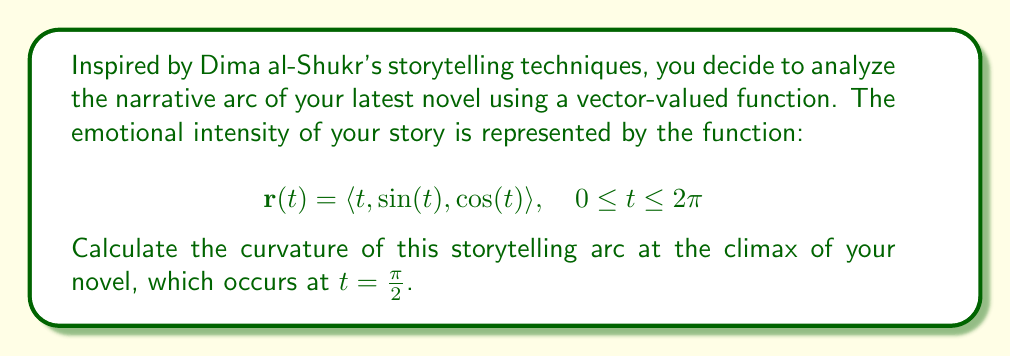What is the answer to this math problem? To calculate the curvature of a vector-valued function, we use the formula:

$$\kappa = \frac{|\mathbf{r}'(t) \times \mathbf{r}''(t)|}{|\mathbf{r}'(t)|^3}$$

Let's follow these steps:

1) First, calculate $\mathbf{r}'(t)$:
   $$\mathbf{r}'(t) = \langle 1, \cos(t), -\sin(t) \rangle$$

2) Then, calculate $\mathbf{r}''(t)$:
   $$\mathbf{r}''(t) = \langle 0, -\sin(t), -\cos(t) \rangle$$

3) Now, calculate $\mathbf{r}'(t) \times \mathbf{r}''(t)$:
   $$\begin{align}
   \mathbf{r}'(t) \times \mathbf{r}''(t) &= \begin{vmatrix} 
   \mathbf{i} & \mathbf{j} & \mathbf{k} \\
   1 & \cos(t) & -\sin(t) \\
   0 & -\sin(t) & -\cos(t)
   \end{vmatrix} \\
   &= \langle -\cos^2(t) - \sin^2(t), \sin(t), -\cos(t) \rangle \\
   &= \langle -1, \sin(t), -\cos(t) \rangle
   \end{align}$$

4) Calculate $|\mathbf{r}'(t) \times \mathbf{r}''(t)|$:
   $$|\mathbf{r}'(t) \times \mathbf{r}''(t)| = \sqrt{(-1)^2 + \sin^2(t) + \cos^2(t)} = \sqrt{2}$$

5) Calculate $|\mathbf{r}'(t)|$:
   $$|\mathbf{r}'(t)| = \sqrt{1^2 + \cos^2(t) + \sin^2(t)} = \sqrt{2}$$

6) Now, we can calculate the curvature:
   $$\kappa = \frac{|\mathbf{r}'(t) \times \mathbf{r}''(t)|}{|\mathbf{r}'(t)|^3} = \frac{\sqrt{2}}{(\sqrt{2})^3} = \frac{1}{\sqrt{2}}$$

This curvature is constant for all $t$, including at the climax where $t = \frac{\pi}{2}$.
Answer: The curvature of the storytelling arc at the climax (and at all points) is $\frac{1}{\sqrt{2}}$. 